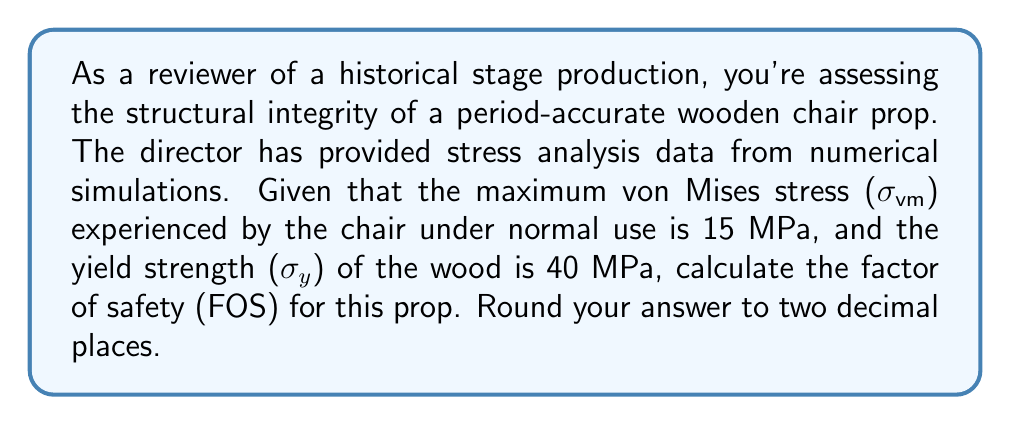Solve this math problem. To determine the structural integrity of the wooden chair prop, we need to calculate the factor of safety (FOS). The FOS is a measure of how much stronger the prop is than it needs to be for its intended use. It's calculated by dividing the yield strength of the material by the maximum stress experienced.

Step 1: Identify the given values
- Maximum von Mises stress ($\sigma_{vm}$) = 15 MPa
- Yield strength of wood ($\sigma_y$) = 40 MPa

Step 2: Apply the formula for Factor of Safety (FOS)
$$ FOS = \frac{\sigma_y}{\sigma_{vm}} $$

Step 3: Substitute the values and calculate
$$ FOS = \frac{40 \text{ MPa}}{15 \text{ MPa}} = 2.6666... $$

Step 4: Round the result to two decimal places
$$ FOS \approx 2.67 $$

This factor of safety indicates that the chair prop can withstand about 2.67 times the expected maximum stress before yielding. Generally, a FOS greater than 1 is considered safe, with higher values providing more assurance of structural integrity.
Answer: 2.67 